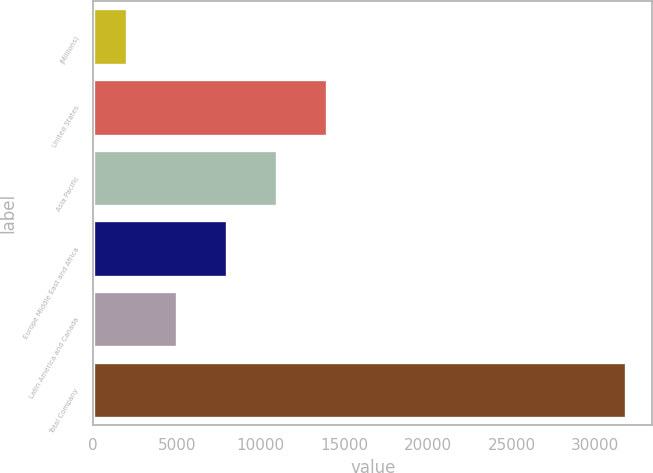Convert chart to OTSL. <chart><loc_0><loc_0><loc_500><loc_500><bar_chart><fcel>(Millions)<fcel>United States<fcel>Asia Pacific<fcel>Europe Middle East and Africa<fcel>Latin America and Canada<fcel>Total Company<nl><fcel>2014<fcel>13936.8<fcel>10956.1<fcel>7975.4<fcel>4994.7<fcel>31821<nl></chart> 